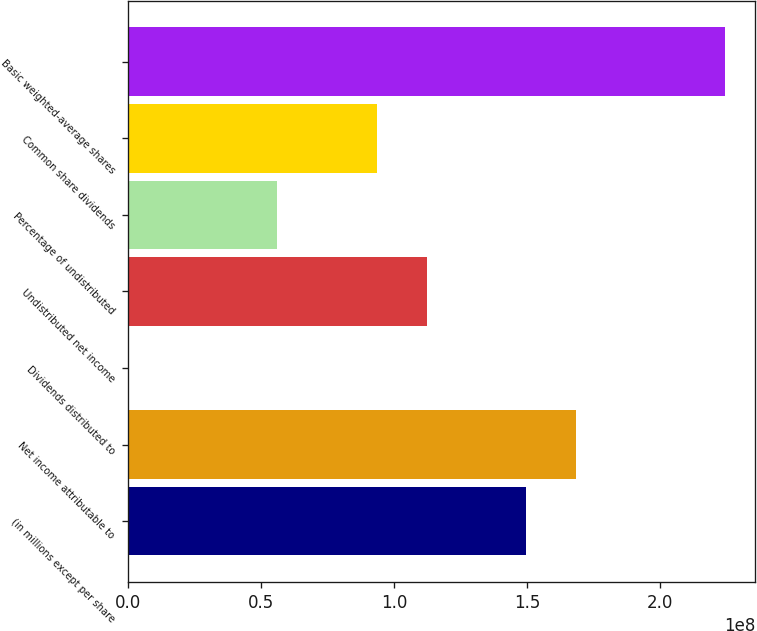<chart> <loc_0><loc_0><loc_500><loc_500><bar_chart><fcel>(in millions except per share<fcel>Net income attributable to<fcel>Dividends distributed to<fcel>Undistributed net income<fcel>Percentage of undistributed<fcel>Common share dividends<fcel>Basic weighted-average shares<nl><fcel>1.49693e+08<fcel>1.68405e+08<fcel>10<fcel>1.1227e+08<fcel>5.61349e+07<fcel>9.35582e+07<fcel>2.2454e+08<nl></chart> 